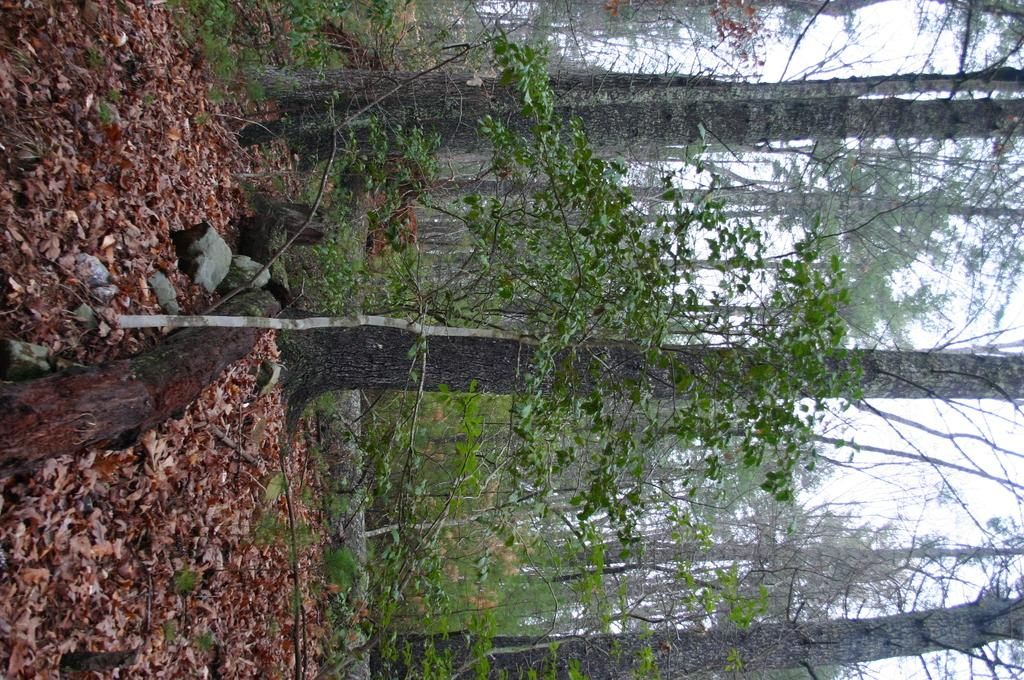What type of vegetation is in the front of the image? There are plants in the front of the image. What can be seen on the left side of the image? There are dry leaves on the left side of the image. What is visible in the background of the image? There are trees in the background of the image. What type of lock can be seen on the tree in the image? There is no lock present on any tree in the image. What type of brush is being used to clean the dry leaves in the image? There is no brush or cleaning activity depicted in the image. 